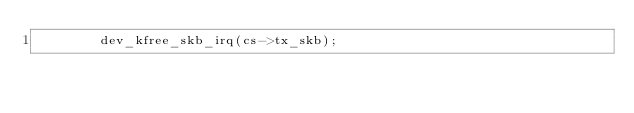Convert code to text. <code><loc_0><loc_0><loc_500><loc_500><_C_>				dev_kfree_skb_irq(cs->tx_skb);</code> 